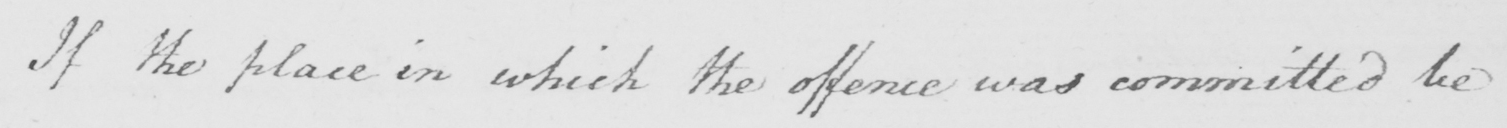Transcribe the text shown in this historical manuscript line. If the place in which the offence was committed be 